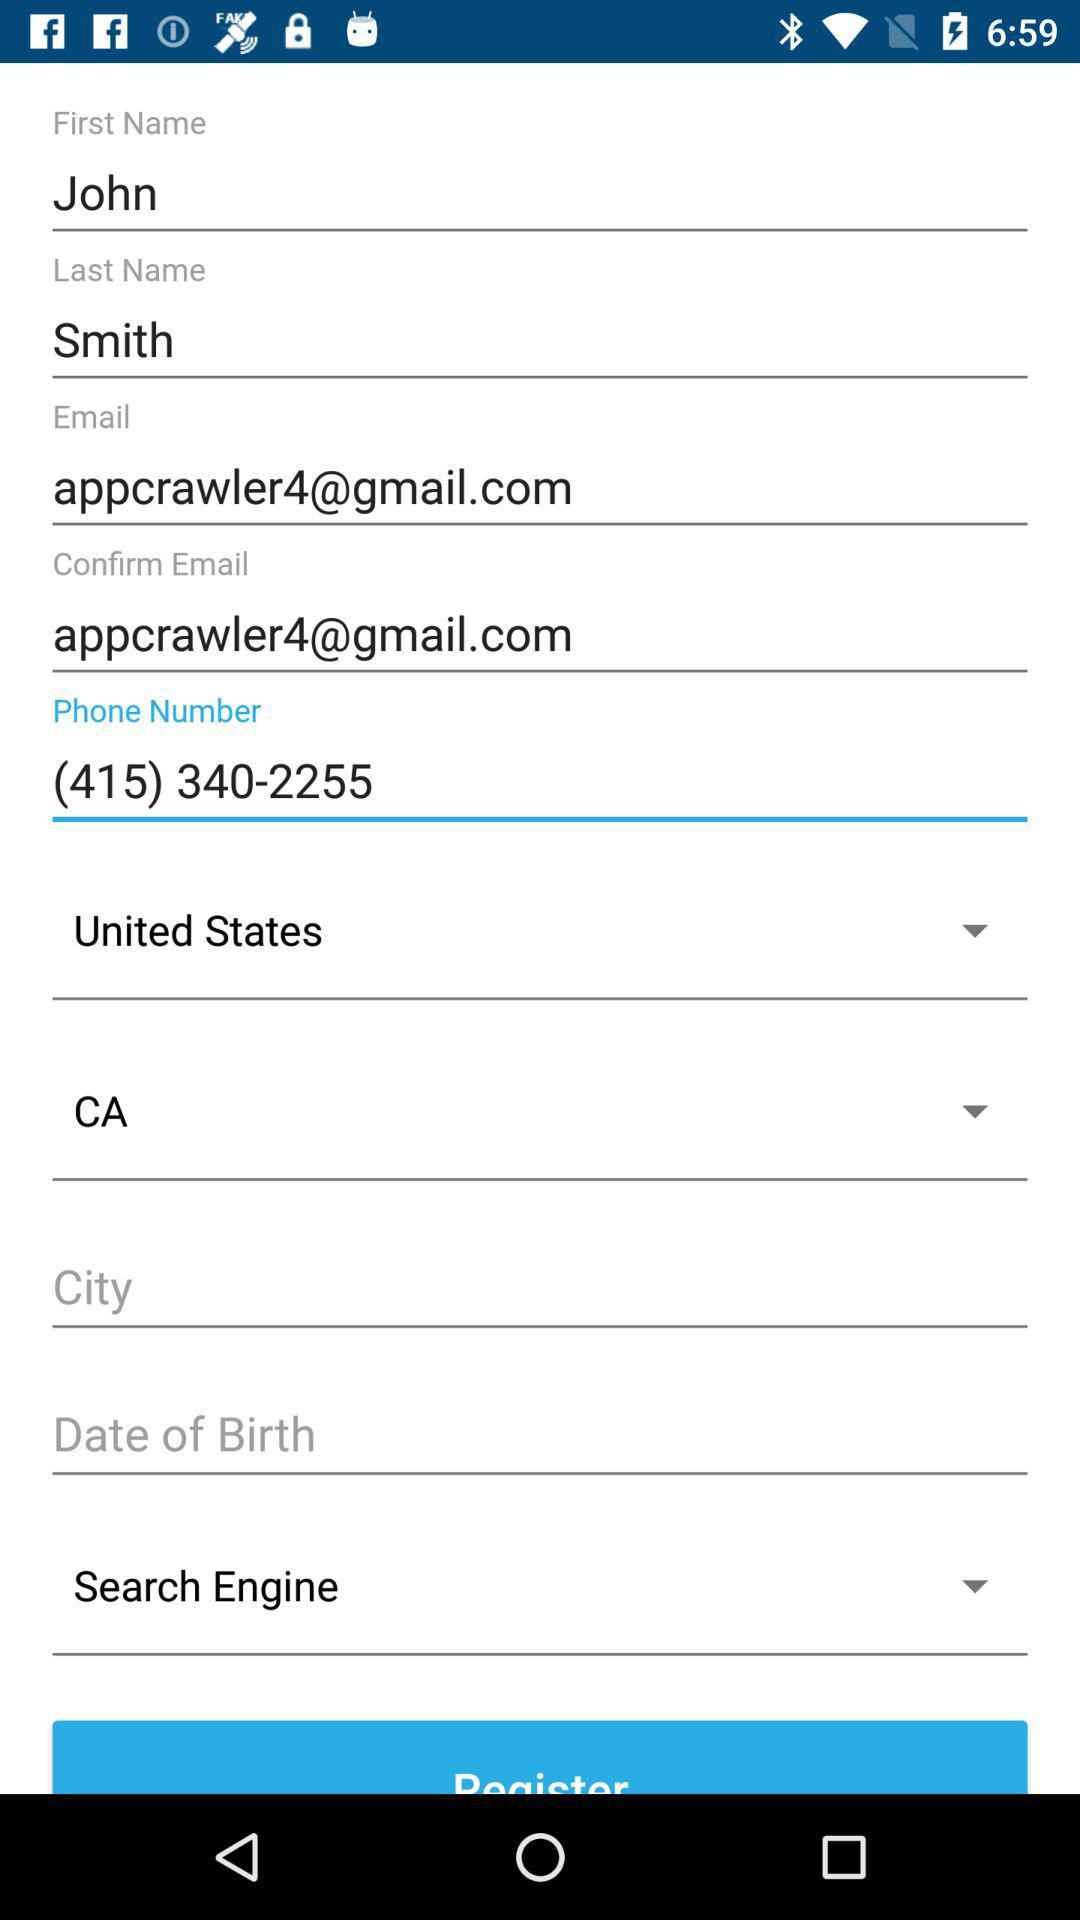What is the location of the user? The user is located in California, United States. 